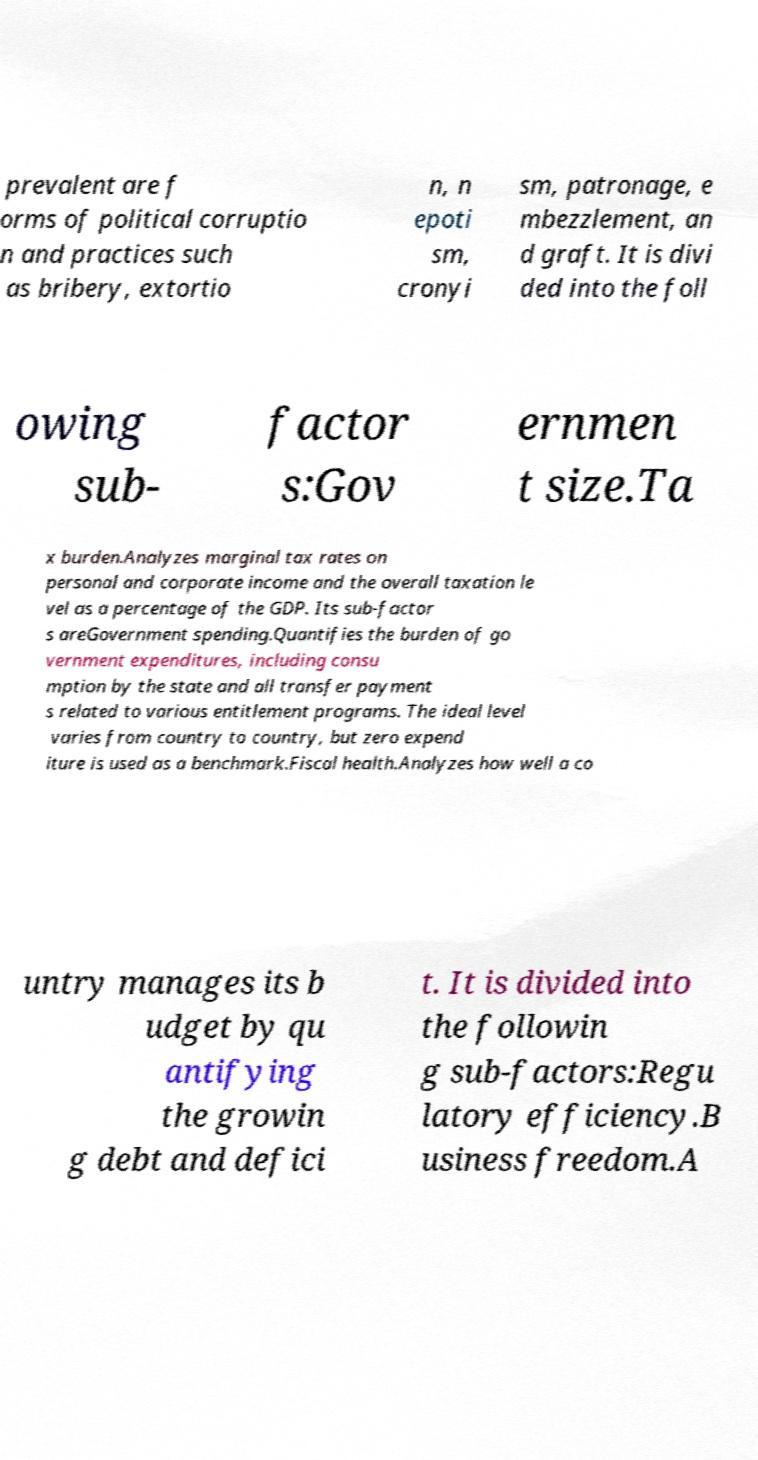I need the written content from this picture converted into text. Can you do that? prevalent are f orms of political corruptio n and practices such as bribery, extortio n, n epoti sm, cronyi sm, patronage, e mbezzlement, an d graft. It is divi ded into the foll owing sub- factor s:Gov ernmen t size.Ta x burden.Analyzes marginal tax rates on personal and corporate income and the overall taxation le vel as a percentage of the GDP. Its sub-factor s areGovernment spending.Quantifies the burden of go vernment expenditures, including consu mption by the state and all transfer payment s related to various entitlement programs. The ideal level varies from country to country, but zero expend iture is used as a benchmark.Fiscal health.Analyzes how well a co untry manages its b udget by qu antifying the growin g debt and defici t. It is divided into the followin g sub-factors:Regu latory efficiency.B usiness freedom.A 